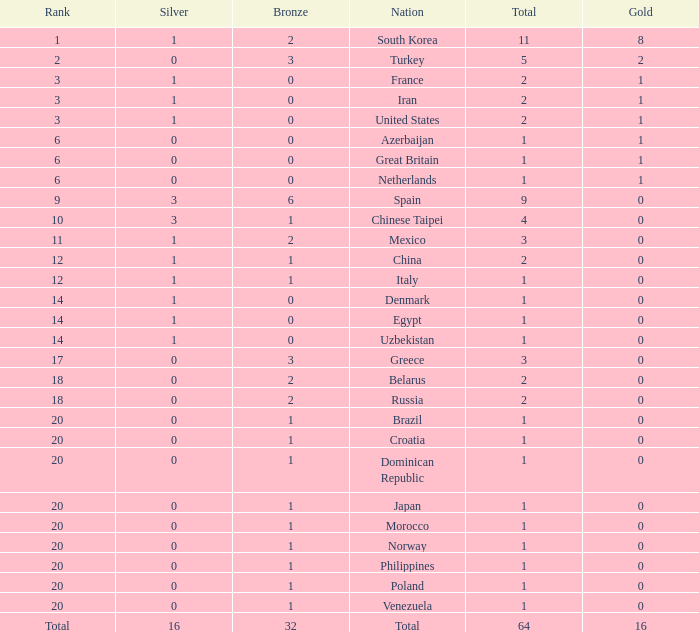What is the average total medals of the nation ranked 1 with less than 1 silver? None. 